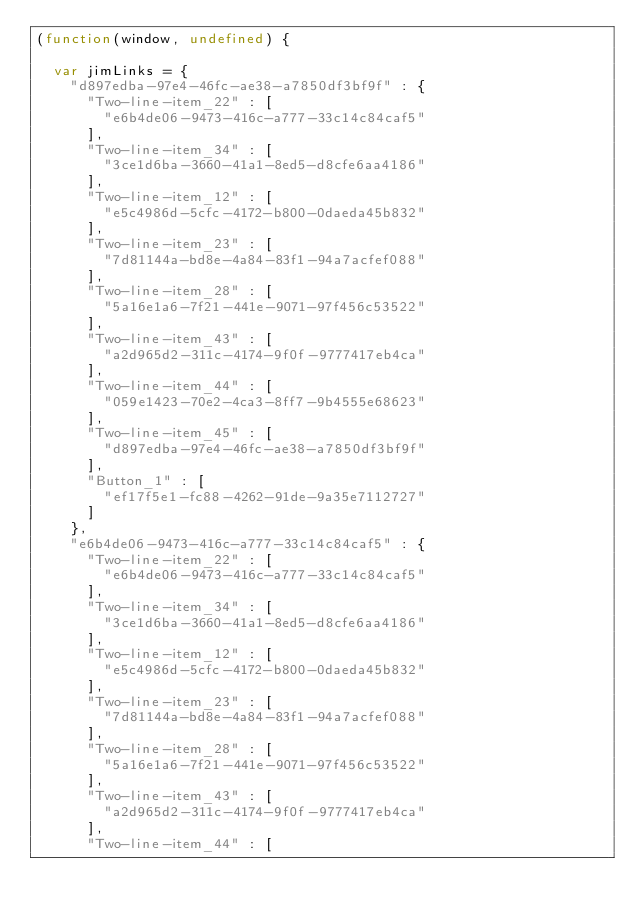<code> <loc_0><loc_0><loc_500><loc_500><_JavaScript_>(function(window, undefined) {

  var jimLinks = {
    "d897edba-97e4-46fc-ae38-a7850df3bf9f" : {
      "Two-line-item_22" : [
        "e6b4de06-9473-416c-a777-33c14c84caf5"
      ],
      "Two-line-item_34" : [
        "3ce1d6ba-3660-41a1-8ed5-d8cfe6aa4186"
      ],
      "Two-line-item_12" : [
        "e5c4986d-5cfc-4172-b800-0daeda45b832"
      ],
      "Two-line-item_23" : [
        "7d81144a-bd8e-4a84-83f1-94a7acfef088"
      ],
      "Two-line-item_28" : [
        "5a16e1a6-7f21-441e-9071-97f456c53522"
      ],
      "Two-line-item_43" : [
        "a2d965d2-311c-4174-9f0f-9777417eb4ca"
      ],
      "Two-line-item_44" : [
        "059e1423-70e2-4ca3-8ff7-9b4555e68623"
      ],
      "Two-line-item_45" : [
        "d897edba-97e4-46fc-ae38-a7850df3bf9f"
      ],
      "Button_1" : [
        "ef17f5e1-fc88-4262-91de-9a35e7112727"
      ]
    },
    "e6b4de06-9473-416c-a777-33c14c84caf5" : {
      "Two-line-item_22" : [
        "e6b4de06-9473-416c-a777-33c14c84caf5"
      ],
      "Two-line-item_34" : [
        "3ce1d6ba-3660-41a1-8ed5-d8cfe6aa4186"
      ],
      "Two-line-item_12" : [
        "e5c4986d-5cfc-4172-b800-0daeda45b832"
      ],
      "Two-line-item_23" : [
        "7d81144a-bd8e-4a84-83f1-94a7acfef088"
      ],
      "Two-line-item_28" : [
        "5a16e1a6-7f21-441e-9071-97f456c53522"
      ],
      "Two-line-item_43" : [
        "a2d965d2-311c-4174-9f0f-9777417eb4ca"
      ],
      "Two-line-item_44" : [</code> 